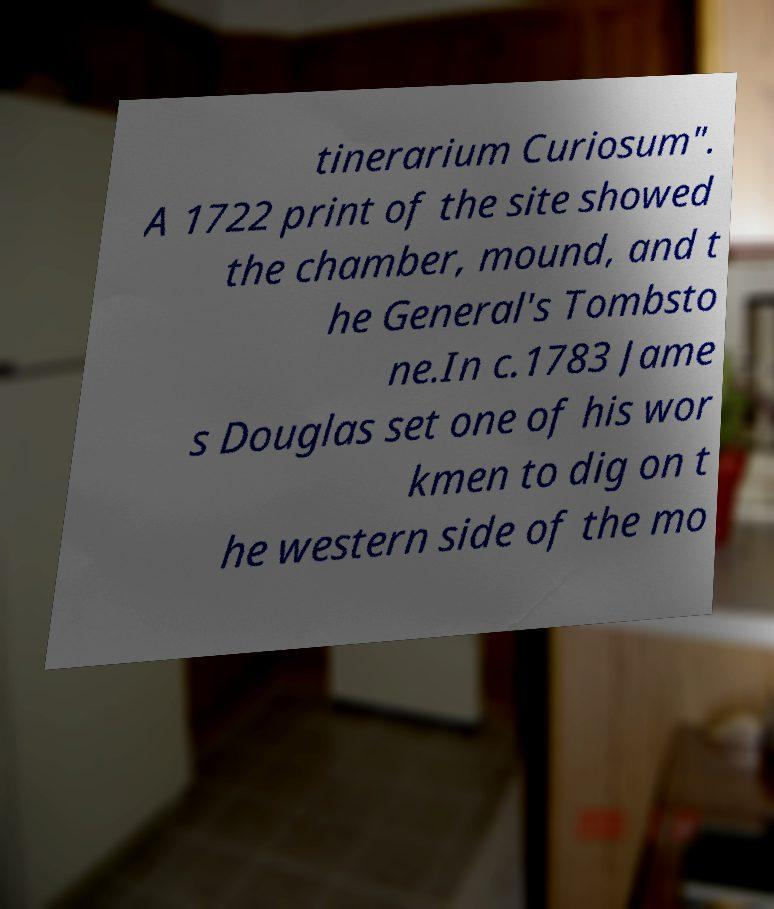Could you extract and type out the text from this image? tinerarium Curiosum". A 1722 print of the site showed the chamber, mound, and t he General's Tombsto ne.In c.1783 Jame s Douglas set one of his wor kmen to dig on t he western side of the mo 